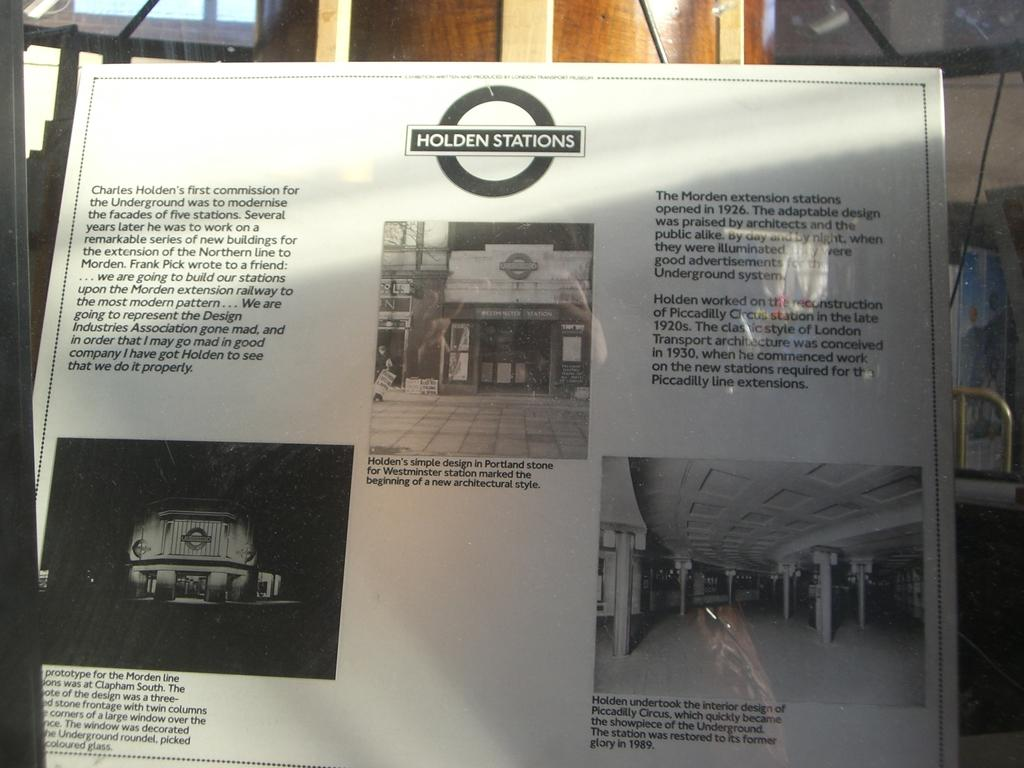<image>
Present a compact description of the photo's key features. A sign includes information about Holden Stations of the underground. 